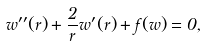<formula> <loc_0><loc_0><loc_500><loc_500>w ^ { \prime \prime } ( r ) + \frac { 2 } { r } w ^ { \prime } ( r ) + f ( w ) = 0 ,</formula> 